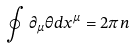Convert formula to latex. <formula><loc_0><loc_0><loc_500><loc_500>\oint \partial _ { \mu } \theta d x ^ { \mu } = 2 \pi n</formula> 